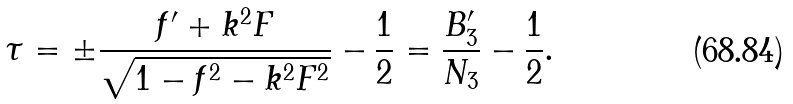Convert formula to latex. <formula><loc_0><loc_0><loc_500><loc_500>\tau = \pm \frac { f ^ { \prime } + k ^ { 2 } F } { \sqrt { 1 - f ^ { 2 } - k ^ { 2 } F ^ { 2 } } } - \frac { 1 } { 2 } = \frac { B _ { 3 } ^ { \prime } } { N _ { 3 } } - \frac { 1 } { 2 } .</formula> 